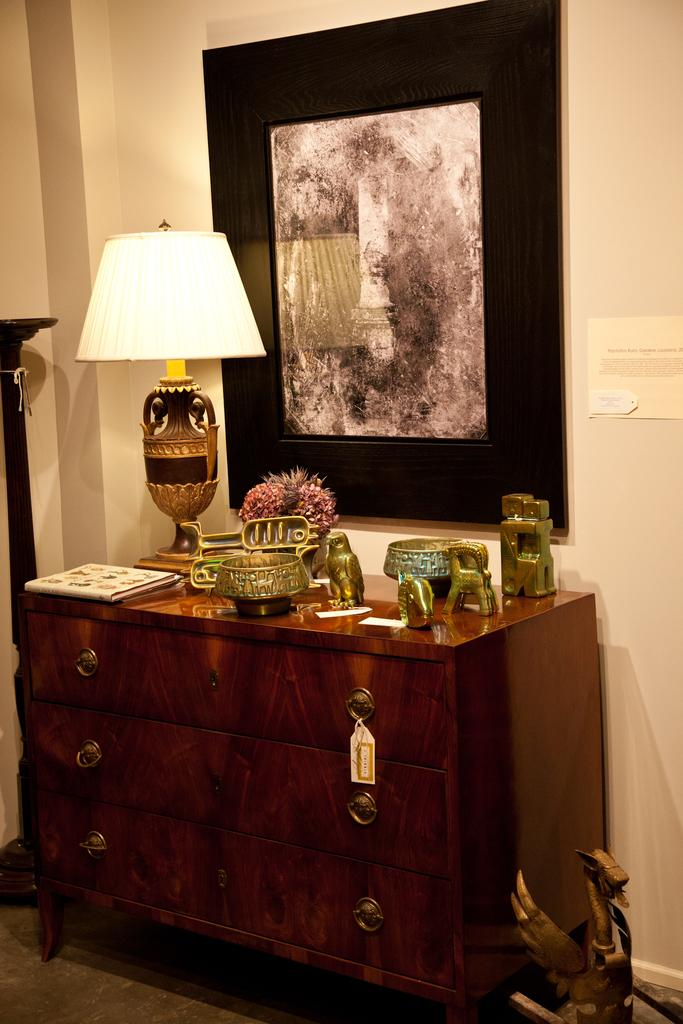What type of lighting fixture is present in the image? There is a lamp in the image. What can be seen in the image besides the lamp? There is a flower vase in the image. Where are the toys located in the image? The toys are on the cupboard in the image. What is hanging on the wall in the background of the image? There is a painting attached to the wall in the background of the image. What is visible in the background of the image? There is a wall visible in the background of the image. How many snakes are crawling on the wall in the image? There are no snakes present in the image; only a lamp, a flower vase, toys, a painting, and a wall are visible. Is there a visitor in the image? There is no indication of a visitor in the image. 